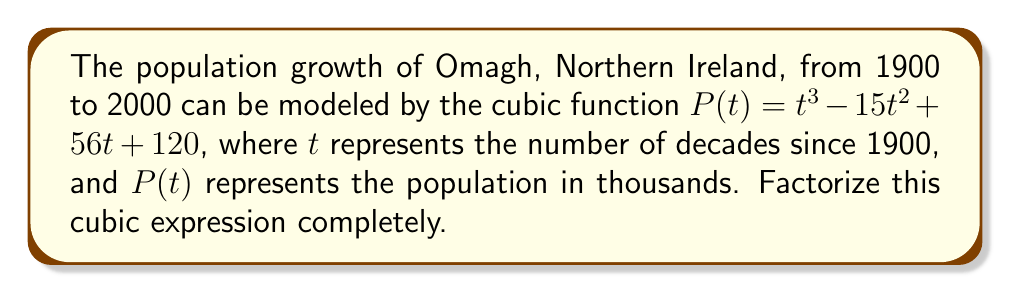Help me with this question. Let's approach this step-by-step:

1) First, we need to check if there are any rational roots. We can use the rational root theorem. The possible rational roots are the factors of the constant term, 120: ±1, ±2, ±3, ±4, ±5, ±6, ±8, ±10, ±12, ±15, ±20, ±24, ±30, ±40, ±60, ±120.

2) Testing these values, we find that $t = 3$ is a root of the polynomial.

3) We can factor out $(t - 3)$:

   $P(t) = (t - 3)(t^2 + at + b)$

4) Expanding this:

   $(t - 3)(t^2 + at + b) = t^3 + at^2 + bt - 3t^2 - 3at - 3b$
                           $= t^3 + (a-3)t^2 + (b-3a)t - 3b$

5) Comparing coefficients with our original polynomial:

   $a - 3 = -15$
   $b - 3a = 56$
   $-3b = 120$

6) From the last equation: $b = -40$

7) From the first equation: $a = -12$

8) We can verify these satisfy the second equation: $-40 - 3(-12) = -40 + 36 = -4 = 56$

9) So our quadratic factor is $t^2 - 12t - 40$

10) This quadratic can be factored further: $(t - 8)(t - 4)$

Therefore, the complete factorization is:

$P(t) = (t - 3)(t - 8)(t - 4)$
Answer: $(t - 3)(t - 8)(t - 4)$ 